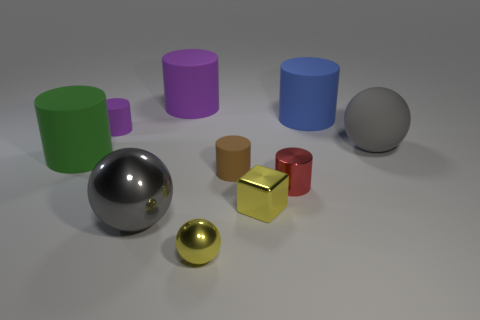Subtract all cyan cubes. How many gray balls are left? 2 Subtract all shiny balls. How many balls are left? 1 Subtract all red cylinders. How many cylinders are left? 5 Subtract 1 cylinders. How many cylinders are left? 5 Subtract all blocks. How many objects are left? 9 Subtract all brown cylinders. Subtract all brown cubes. How many cylinders are left? 5 Subtract all small purple matte cylinders. Subtract all brown cylinders. How many objects are left? 8 Add 1 metal blocks. How many metal blocks are left? 2 Add 9 yellow shiny spheres. How many yellow shiny spheres exist? 10 Subtract 0 green cubes. How many objects are left? 10 